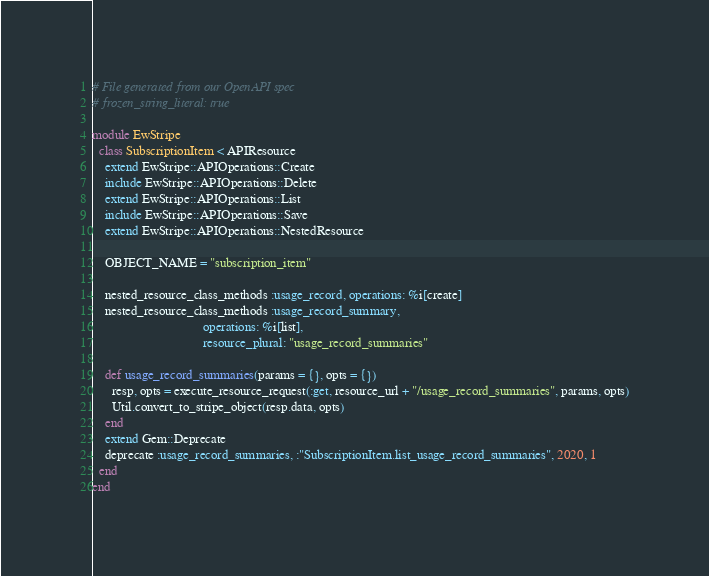<code> <loc_0><loc_0><loc_500><loc_500><_Ruby_># File generated from our OpenAPI spec
# frozen_string_literal: true

module EwStripe
  class SubscriptionItem < APIResource
    extend EwStripe::APIOperations::Create
    include EwStripe::APIOperations::Delete
    extend EwStripe::APIOperations::List
    include EwStripe::APIOperations::Save
    extend EwStripe::APIOperations::NestedResource

    OBJECT_NAME = "subscription_item"

    nested_resource_class_methods :usage_record, operations: %i[create]
    nested_resource_class_methods :usage_record_summary,
                                  operations: %i[list],
                                  resource_plural: "usage_record_summaries"

    def usage_record_summaries(params = {}, opts = {})
      resp, opts = execute_resource_request(:get, resource_url + "/usage_record_summaries", params, opts)
      Util.convert_to_stripe_object(resp.data, opts)
    end
    extend Gem::Deprecate
    deprecate :usage_record_summaries, :"SubscriptionItem.list_usage_record_summaries", 2020, 1
  end
end
</code> 